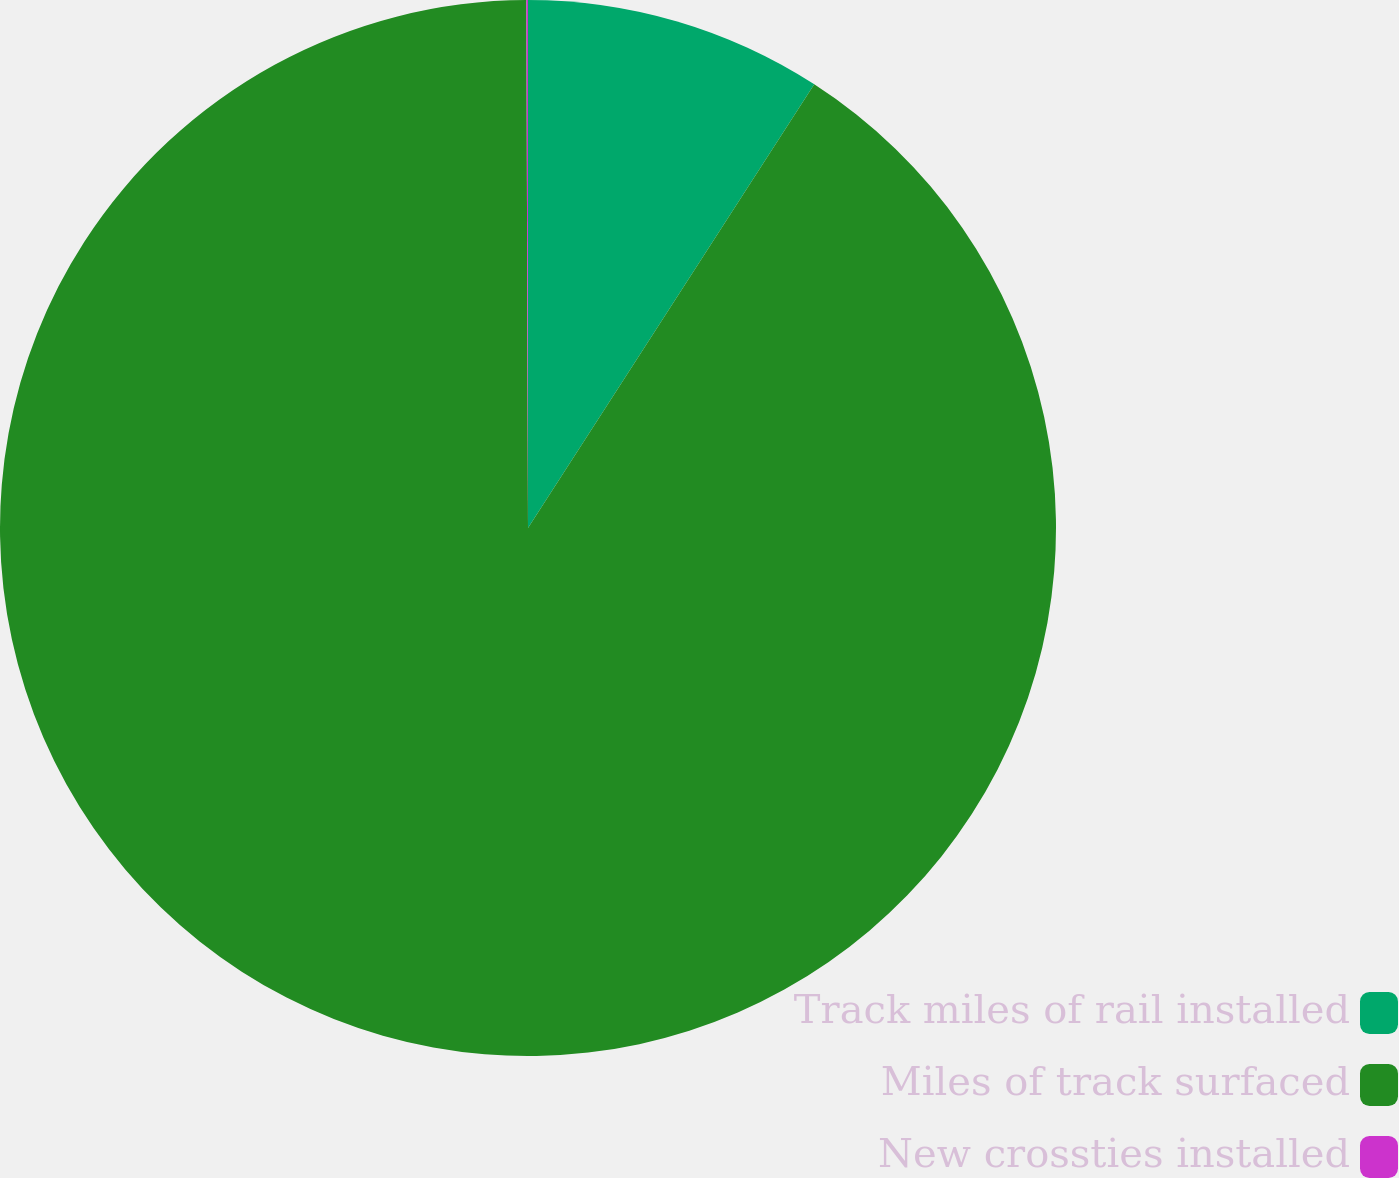Convert chart to OTSL. <chart><loc_0><loc_0><loc_500><loc_500><pie_chart><fcel>Track miles of rail installed<fcel>Miles of track surfaced<fcel>New crossties installed<nl><fcel>9.12%<fcel>90.83%<fcel>0.05%<nl></chart> 